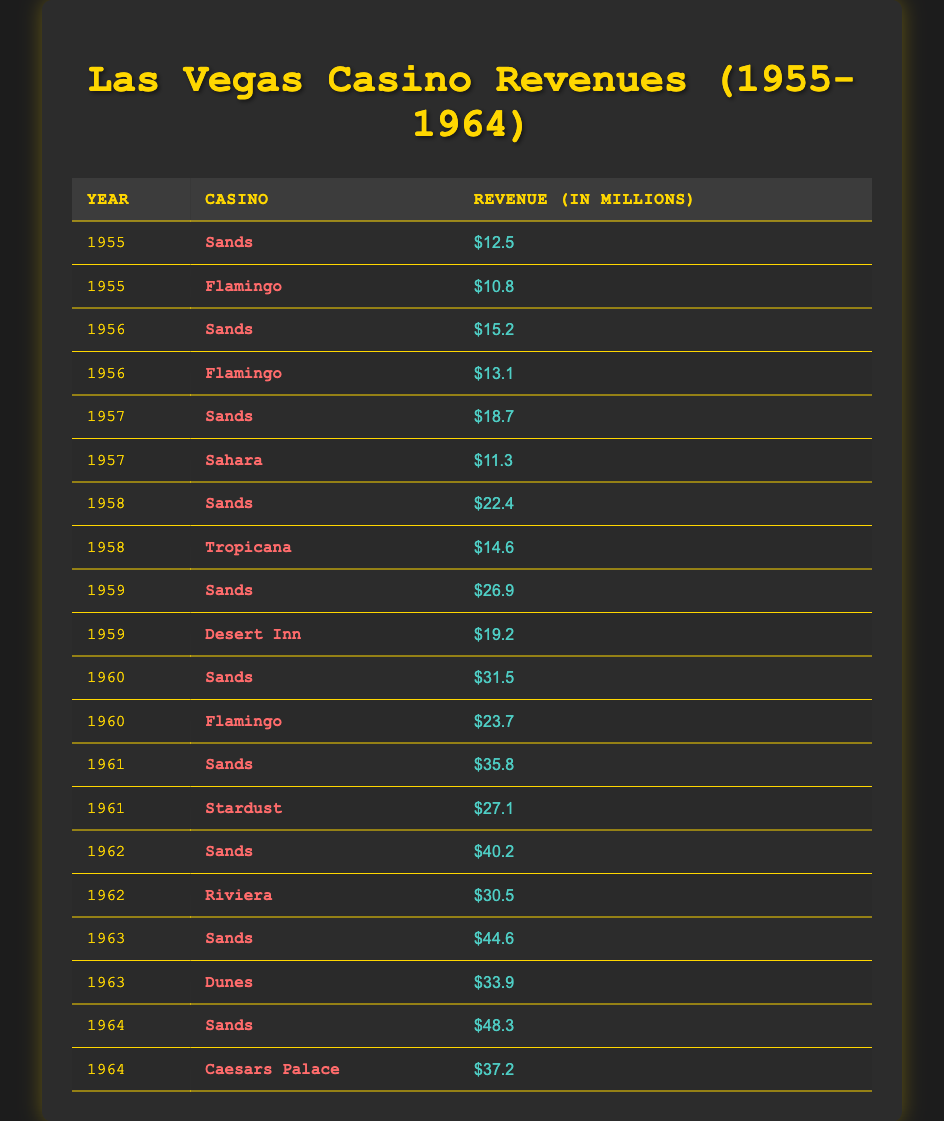What year did the Sands Casino first exceed $20 million in revenue? The table shows the revenue for the Sands Casino for the years listed. Looking closely, the first year that the revenue exceeds $20 million is 1958, when it reached $22.4 million.
Answer: 1958 What was the total revenue earned by the Flamingo from 1955 to 1960? To find this, we locate the Flamingo's revenue for each year: 1955: $10.8 million, 1956: $13.1 million, 1960: $23.7 million. There is no revenue for 1957 and 1959. The total is $10.8 + $13.1 + $23.7 = $47.6 million.
Answer: $47.6 million Did the Sahara Casino have higher revenues than the Tropicana in any year? Checking the revenues, the Sahara earned $11.3 million in 1957, while the Tropicana earned $14.6 million in 1958. The Sahara did not exceed the Tropicana's revenue in any year listed.
Answer: No What was the average revenue of the Sands Casino from 1955 to 1964? The revenues for the Sands in the respective years are: 1955: $12.5 million, 1956: $15.2 million, 1957: $18.7 million, 1958: $22.4 million, 1959: $26.9 million, 1960: $31.5 million, 1961: $35.8 million, 1962: $40.2 million, 1963: $44.6 million, 1964: $48.3 million. Summing these gives $12.5 + $15.2 + $18.7 + $22.4 + $26.9 + $31.5 + $35.8 + $40.2 + $44.6 + $48.3 = $355.1 million. Divide by the number of years (10) to find the average: $355.1 / 10 = $35.51 million.
Answer: $35.51 million Which casino had the highest revenue in 1963 and what was that revenue? In 1963, the table shows Sands with $44.6 million and Dunes with $33.9 million. Clearly, Sands had the highest revenue that year.
Answer: Sands, $44.6 million 